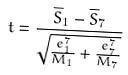<formula> <loc_0><loc_0><loc_500><loc_500>t = \frac { \overline { S } _ { 1 } - \overline { S } _ { 7 } } { \sqrt { \frac { e _ { 1 } ^ { 7 } } { M _ { 1 } } + \frac { e _ { 7 } ^ { 7 } } { M _ { 7 } } } }</formula> 